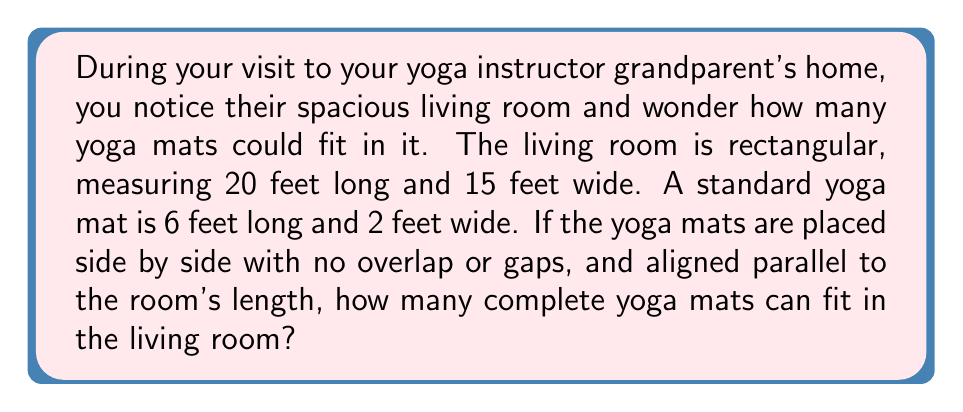Provide a solution to this math problem. To solve this problem, we need to determine how many yoga mats can fit along the width and length of the room:

1. Calculate the number of mats that can fit along the room's width:
   $$ \text{Mats along width} = \left\lfloor\frac{\text{Room width}}{\text{Mat width}}\right\rfloor = \left\lfloor\frac{15 \text{ feet}}{2 \text{ feet}}\right\rfloor = 7 \text{ mats} $$

2. Calculate the number of mats that can fit along the room's length:
   $$ \text{Mats along length} = \left\lfloor\frac{\text{Room length}}{\text{Mat length}}\right\rfloor = \left\lfloor\frac{20 \text{ feet}}{6 \text{ feet}}\right\rfloor = 3 \text{ mats} $$

3. Multiply the number of mats that can fit along the width by the number of mats that can fit along the length:
   $$ \text{Total mats} = \text{Mats along width} \times \text{Mats along length} = 7 \times 3 = 21 \text{ mats} $$

Note: We use the floor function $\lfloor \rfloor$ to ensure we only count complete mats.

[asy]
unitsize(10);
draw((0,0)--(20,0)--(20,15)--(0,15)--cycle);
for(int i=0; i<7; ++i) {
  for(int j=0; j<3; ++j) {
    draw((i*2,j*6)--((i+1)*2,j*6)--((i+1)*2,(j+1)*6)--(i*2,(j+1)*6)--cycle);
  }
}
label("20 feet", (10,-0.5));
label("15 feet", (20.5,7.5), E);
label("6 feet", (21,3), E);
label("2 feet", (1,15.5), N);
[/asy]
Answer: 21 yoga mats 